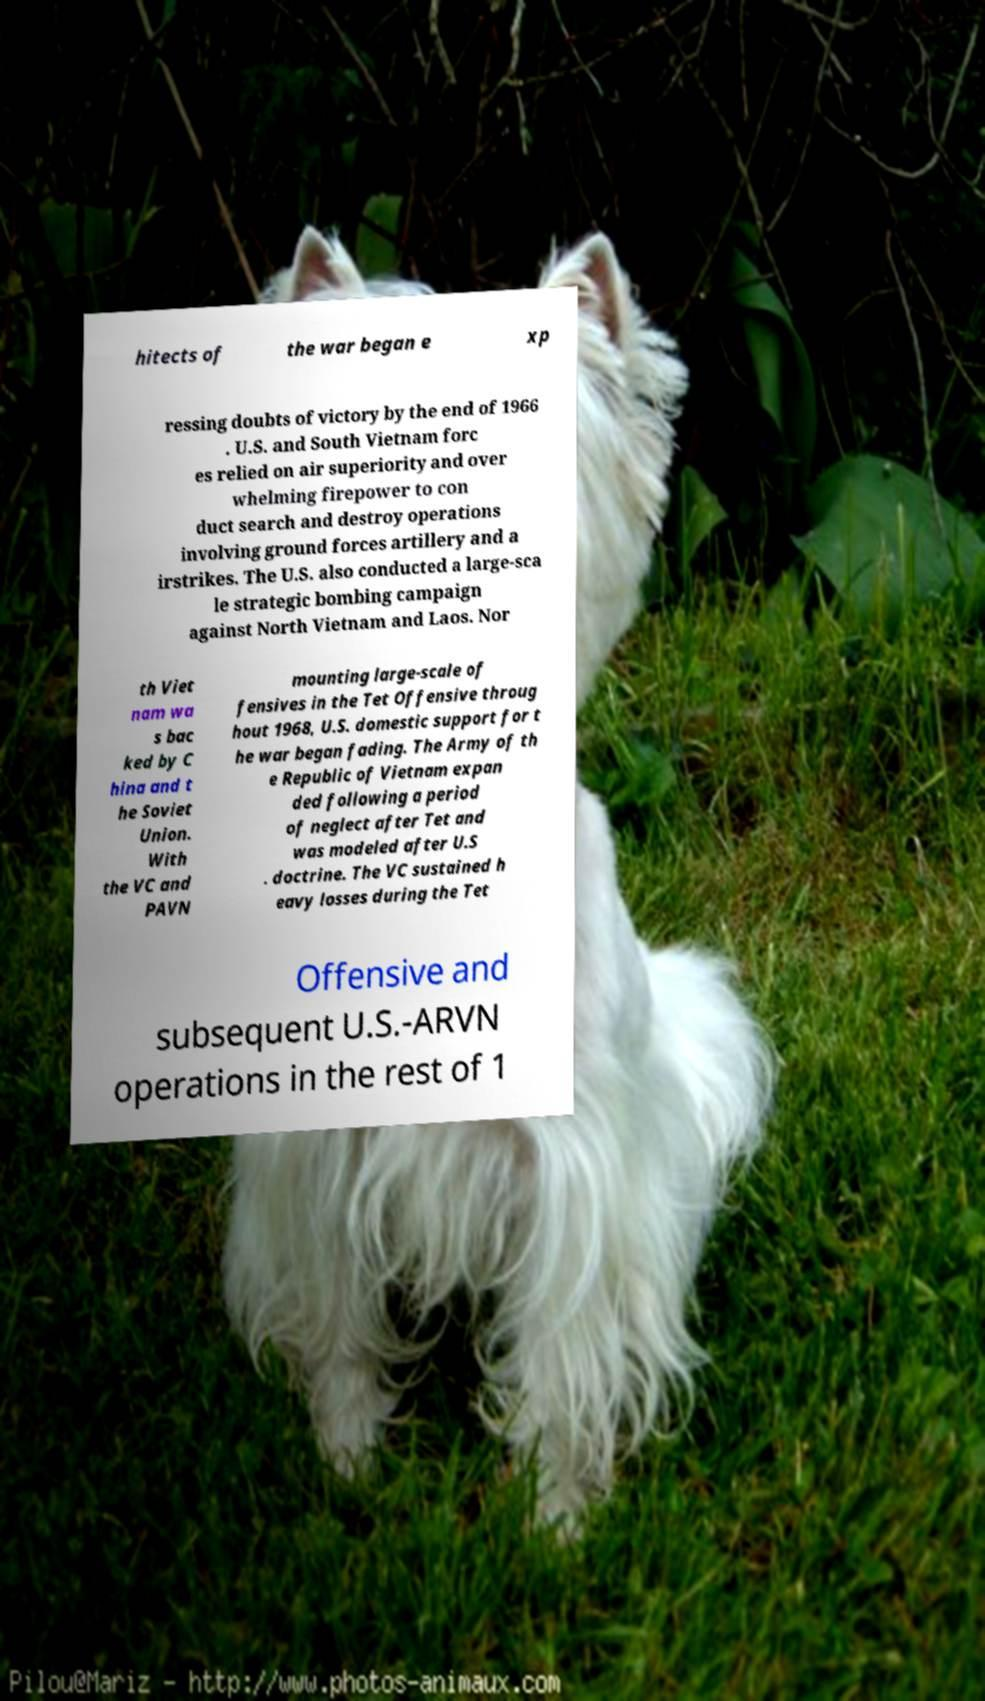For documentation purposes, I need the text within this image transcribed. Could you provide that? hitects of the war began e xp ressing doubts of victory by the end of 1966 . U.S. and South Vietnam forc es relied on air superiority and over whelming firepower to con duct search and destroy operations involving ground forces artillery and a irstrikes. The U.S. also conducted a large-sca le strategic bombing campaign against North Vietnam and Laos. Nor th Viet nam wa s bac ked by C hina and t he Soviet Union. With the VC and PAVN mounting large-scale of fensives in the Tet Offensive throug hout 1968, U.S. domestic support for t he war began fading. The Army of th e Republic of Vietnam expan ded following a period of neglect after Tet and was modeled after U.S . doctrine. The VC sustained h eavy losses during the Tet Offensive and subsequent U.S.-ARVN operations in the rest of 1 